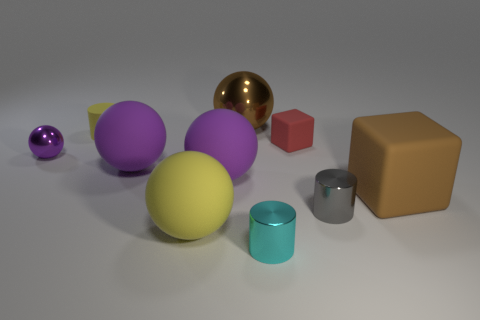Are there any big yellow matte things that have the same shape as the brown rubber object?
Ensure brevity in your answer.  No. What number of matte cylinders are on the left side of the yellow cylinder?
Give a very brief answer. 0. There is a brown object that is to the left of the large brown cube on the right side of the matte cylinder; what is it made of?
Your answer should be very brief. Metal. There is a block that is the same size as the brown sphere; what material is it?
Provide a succinct answer. Rubber. Is there a brown rubber thing of the same size as the brown metal sphere?
Provide a short and direct response. Yes. There is a small metal thing on the right side of the tiny cyan shiny object; what color is it?
Offer a terse response. Gray. There is a matte cube that is behind the tiny purple metal sphere; are there any objects that are on the left side of it?
Ensure brevity in your answer.  Yes. How many other objects are the same color as the tiny shiny sphere?
Offer a terse response. 2. Does the brown thing that is to the right of the cyan object have the same size as the brown object to the left of the tiny red matte cube?
Your response must be concise. Yes. There is a brown rubber thing on the right side of the large yellow matte thing that is on the left side of the small cyan cylinder; what size is it?
Make the answer very short. Large. 